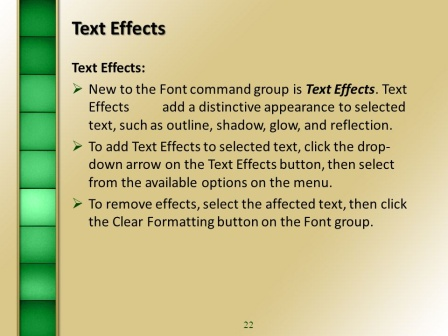What can you infer about the overall theme or subject of the presentation based on this slide? Based on this slide, it can be inferred that the overall theme or subject of the presentation revolves around teaching or demonstrating various features and functionalities of a presentation software. The slide provides specific instructions on using 'Text Effects' within the Font command group, suggesting that the entire presentation could be a detailed guide or tutorial on creating visually appealing and effective presentations. This includes instructions on formatting text, adding graphical elements, and possibly other advanced features available in the software. 